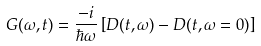Convert formula to latex. <formula><loc_0><loc_0><loc_500><loc_500>G ( \omega , t ) = \frac { - i } { \hbar { \omega } } \left [ D ( t , \omega ) - D ( t , \omega = 0 ) \right ]</formula> 